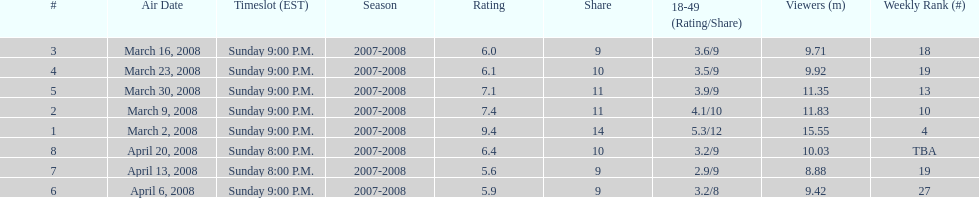Could you help me parse every detail presented in this table? {'header': ['#', 'Air Date', 'Timeslot (EST)', 'Season', 'Rating', 'Share', '18-49 (Rating/Share)', 'Viewers (m)', 'Weekly Rank (#)'], 'rows': [['3', 'March 16, 2008', 'Sunday 9:00 P.M.', '2007-2008', '6.0', '9', '3.6/9', '9.71', '18'], ['4', 'March 23, 2008', 'Sunday 9:00 P.M.', '2007-2008', '6.1', '10', '3.5/9', '9.92', '19'], ['5', 'March 30, 2008', 'Sunday 9:00 P.M.', '2007-2008', '7.1', '11', '3.9/9', '11.35', '13'], ['2', 'March 9, 2008', 'Sunday 9:00 P.M.', '2007-2008', '7.4', '11', '4.1/10', '11.83', '10'], ['1', 'March 2, 2008', 'Sunday 9:00 P.M.', '2007-2008', '9.4', '14', '5.3/12', '15.55', '4'], ['8', 'April 20, 2008', 'Sunday 8:00 P.M.', '2007-2008', '6.4', '10', '3.2/9', '10.03', 'TBA'], ['7', 'April 13, 2008', 'Sunday 8:00 P.M.', '2007-2008', '5.6', '9', '2.9/9', '8.88', '19'], ['6', 'April 6, 2008', 'Sunday 9:00 P.M.', '2007-2008', '5.9', '9', '3.2/8', '9.42', '27']]} Which air date had the least viewers? April 13, 2008. 